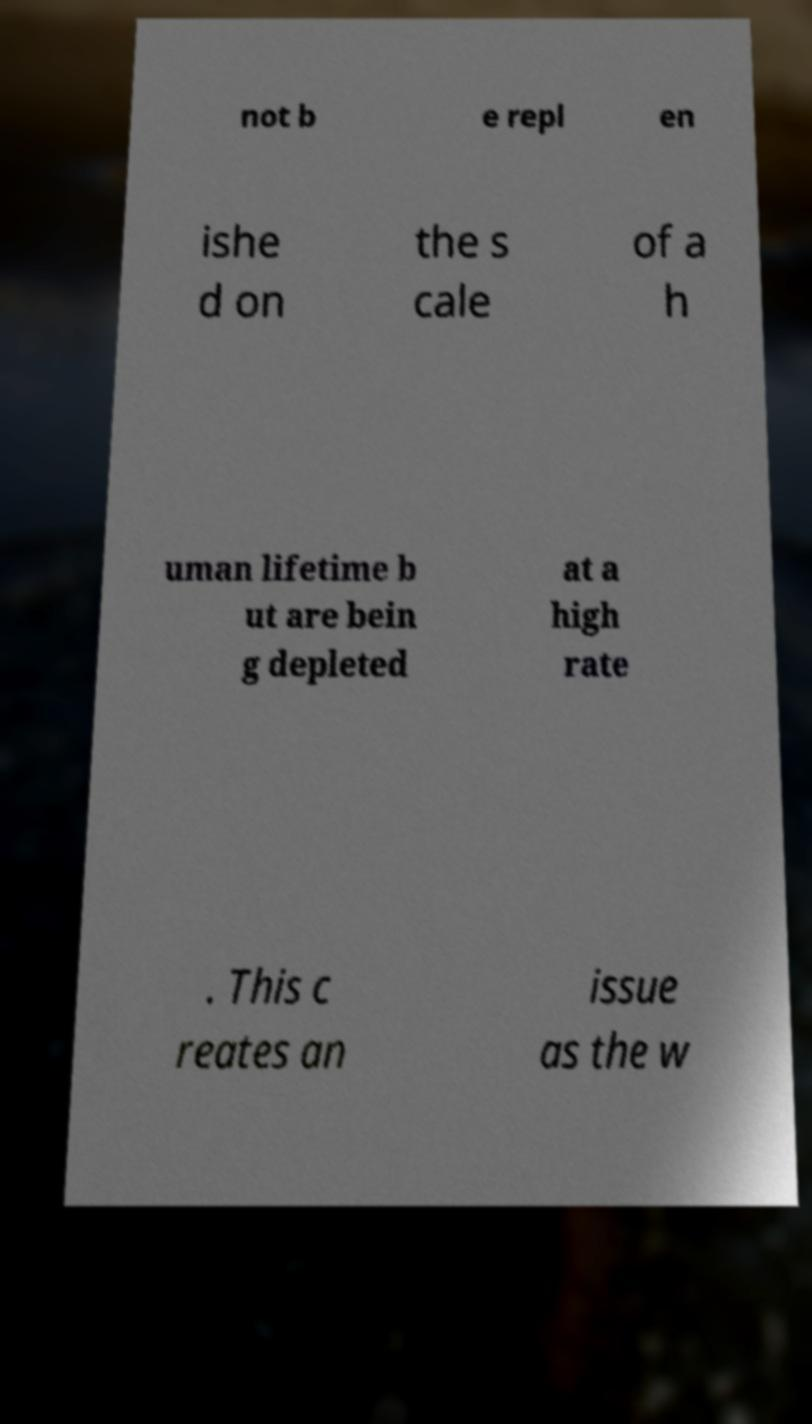Please identify and transcribe the text found in this image. not b e repl en ishe d on the s cale of a h uman lifetime b ut are bein g depleted at a high rate . This c reates an issue as the w 